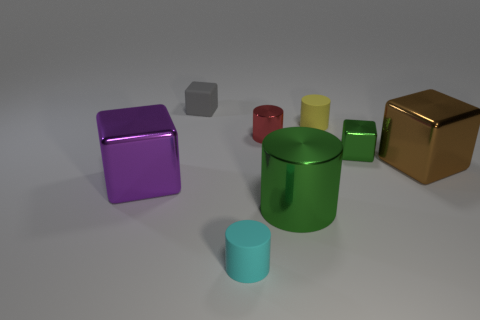Subtract all yellow cylinders. How many cylinders are left? 3 Subtract all tiny cylinders. How many cylinders are left? 1 Subtract 3 cubes. How many cubes are left? 1 Add 1 cylinders. How many objects exist? 9 Subtract 0 brown spheres. How many objects are left? 8 Subtract all red blocks. Subtract all red balls. How many blocks are left? 4 Subtract all brown spheres. How many cyan cylinders are left? 1 Subtract all big purple objects. Subtract all small cyan things. How many objects are left? 6 Add 3 brown objects. How many brown objects are left? 4 Add 3 small cyan objects. How many small cyan objects exist? 4 